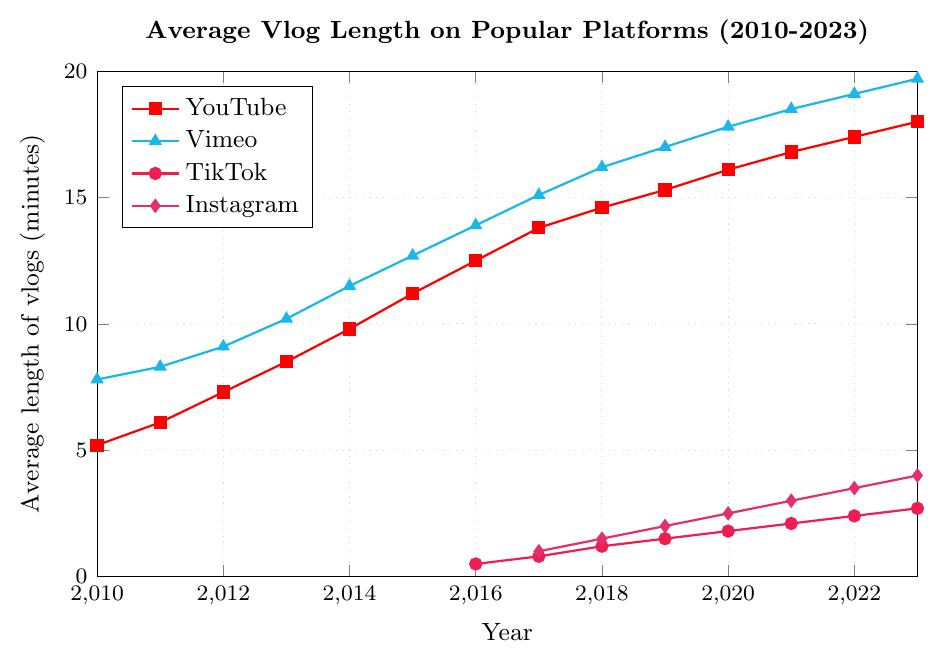Which platform had the longest average vlog length in 2010? Look at the average length values in 2010 for all platforms and compare them. Vimeo is highest at 7.8 minutes.
Answer: Vimeo How did the average vlog length on YouTube change from 2010 to 2023? Subtract the average vlog length on YouTube in 2010 from the length in 2023. That's 18.0 - 5.2. The vlog length increased by 12.8 minutes.
Answer: Increased by 12.8 minutes Between which years did TikTok see the fastest growth in average vlog length? Compare the annual increments of TikTok's average vlog length and find the largest one. TikTok grew fastest from 2022 to 2023 (2.7 - 2.4 = 0.3 minutes).
Answer: 2022-2023 In 2020, which platform had the shortest average vlog length? Look at the values for all platforms in 2020 and find the smallest one. TikTok at 1.8 minutes is the shortest.
Answer: TikTok Compare the growth in average vlog length between YouTube and Vimeo from 2010 to 2023. Subtract the 2010 value from the 2023 value for both YouTube and Vimeo, then compare: 
YouTube: 18.0 - 5.2 = 12.8 
Vimeo: 19.7 - 7.8 = 11.9 
YouTube's growth is greater (12.8 vs. 11.9).
Answer: YouTube grew more What is the difference in average vlog length between Instagram and TikTok in 2023? Subtract TikTok's average vlog length from Instagram's in 2023: 4.0 - 2.7 = 1.3 minutes.
Answer: 1.3 minutes Which platform had a consistently increasing average vlog length from 2010 to 2023? Check if vlog lengths are always increasing year-over-year for each platform. YouTube, Vimeo, TikTok, and Instagram all show constant year-over-year increases.
Answer: YouTube, Vimeo, TikTok, Instagram On which platform did the average length of vlogs first exceed 10 minutes, and in what year? Look at the years when the average vlog lengths first exceed 10 minutes for all platforms. Vimeo first exceeded 10 minutes in 2013.
Answer: Vimeo, 2013 How much did Instagram's average vlog length increase from 2017 to 2023? Subtract Instagram's average vlog length in 2017 from 2023. That's 4.0 - 1.0 = 3.0 minutes.
Answer: 3.0 minutes 